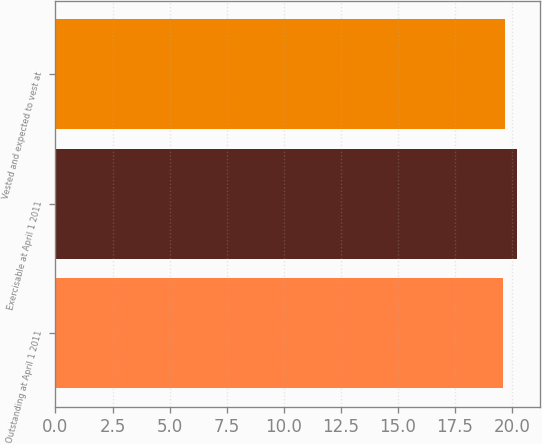Convert chart to OTSL. <chart><loc_0><loc_0><loc_500><loc_500><bar_chart><fcel>Outstanding at April 1 2011<fcel>Exercisable at April 1 2011<fcel>Vested and expected to vest at<nl><fcel>19.61<fcel>20.22<fcel>19.7<nl></chart> 